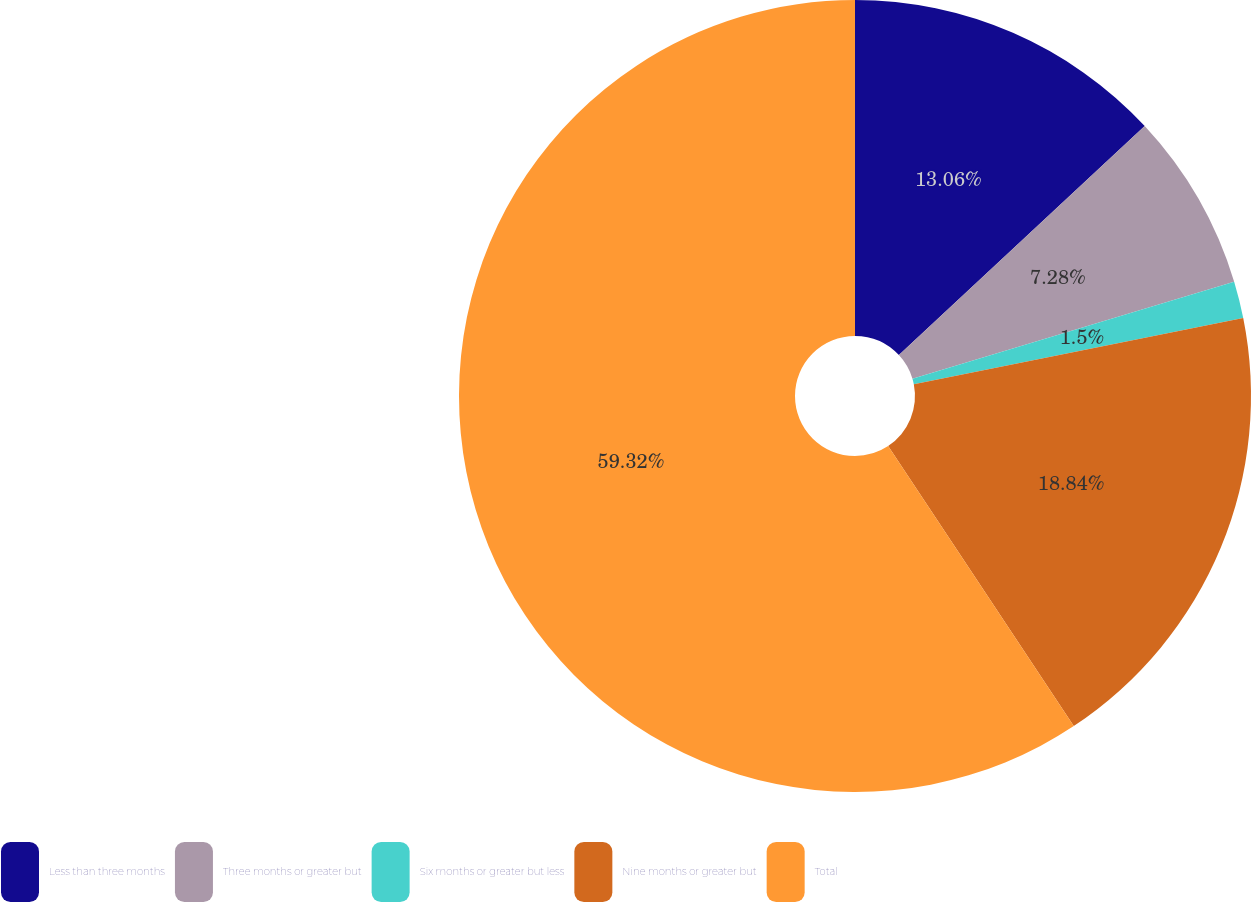Convert chart. <chart><loc_0><loc_0><loc_500><loc_500><pie_chart><fcel>Less than three months<fcel>Three months or greater but<fcel>Six months or greater but less<fcel>Nine months or greater but<fcel>Total<nl><fcel>13.06%<fcel>7.28%<fcel>1.5%<fcel>18.84%<fcel>59.31%<nl></chart> 